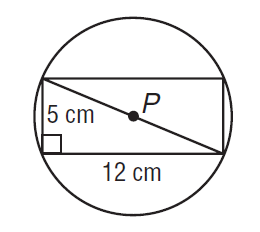Question: Find the exact circumference of \odot P.
Choices:
A. 13
B. 12 \pi
C. 40.84
D. 13 \pi
Answer with the letter. Answer: D 